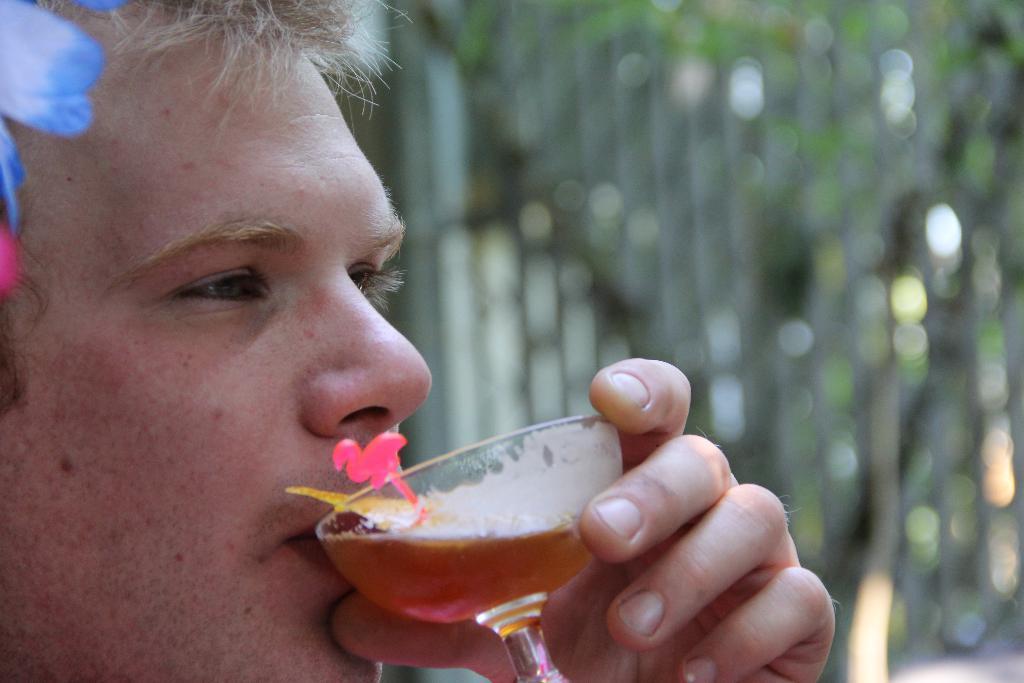How would you summarize this image in a sentence or two? This image consists of a man drinking beer. In the background, there are trees. 